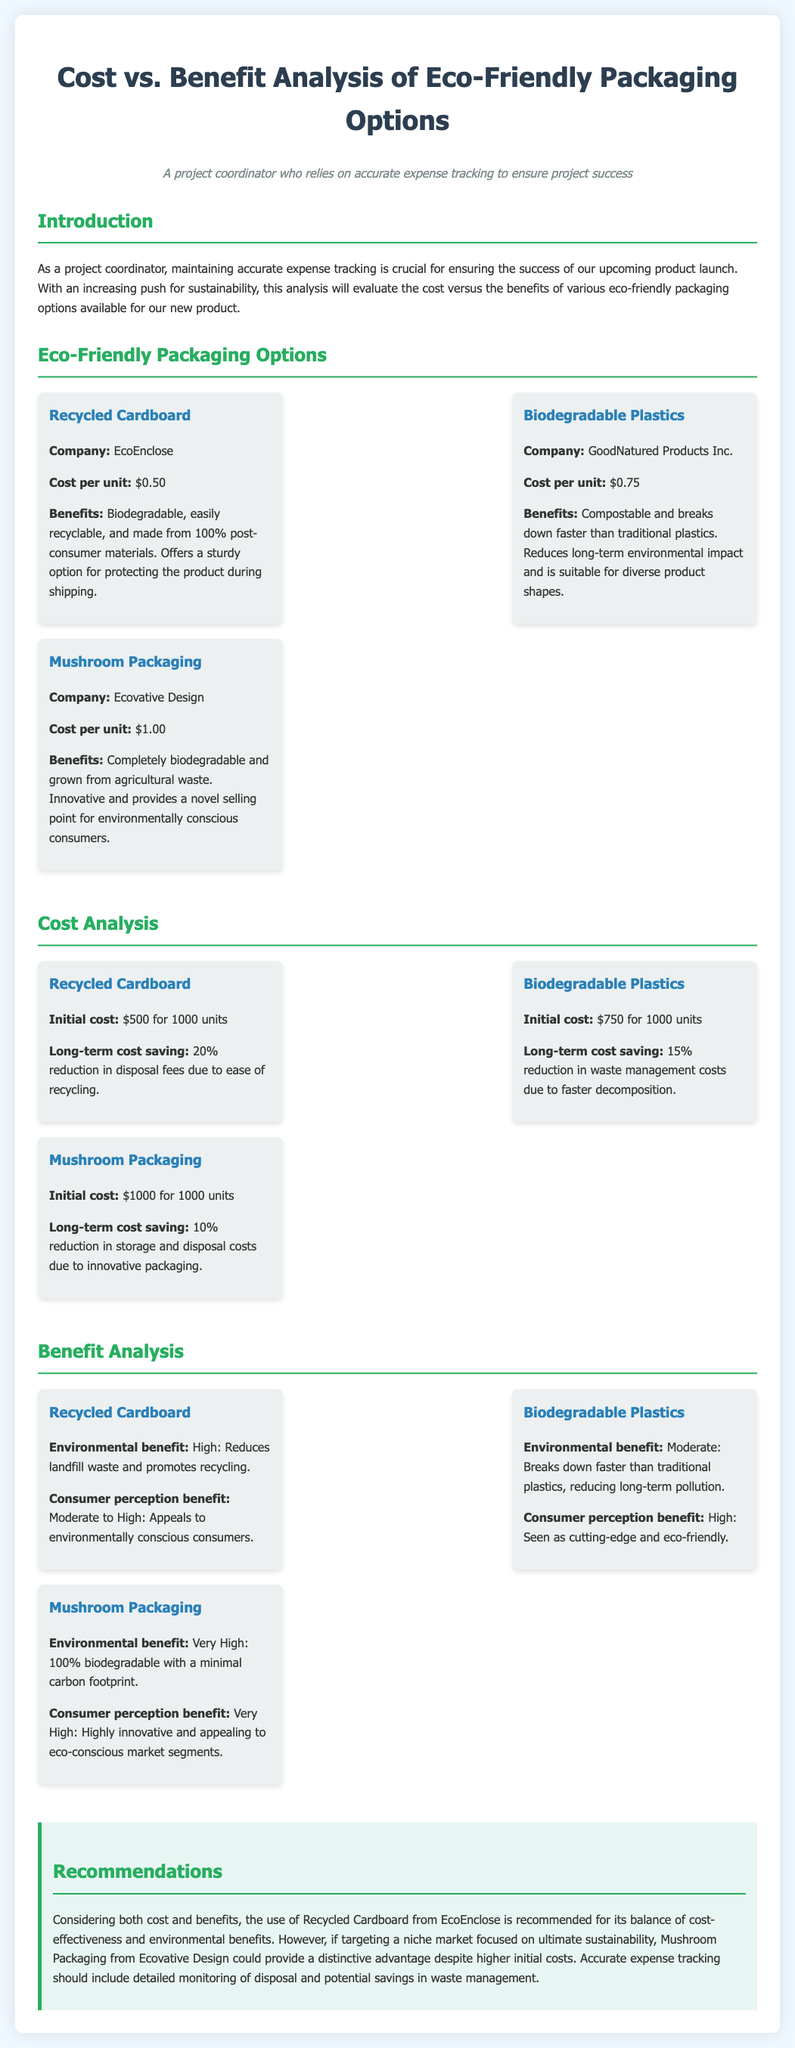What is the cost per unit of Recycled Cardboard? The cost per unit of Recycled Cardboard is provided as $0.50.
Answer: $0.50 What is the initial cost of Mushroom Packaging for 1000 units? The document states that the initial cost of Mushroom Packaging is $1000 for 1000 units.
Answer: $1000 Which option offers a 20% reduction in disposal fees? The analysis indicates that Recycled Cardboard offers a 20% reduction in disposal fees due to ease of recycling.
Answer: Recycled Cardboard What company produces Biodegradable Plastics? The company that produces Biodegradable Plastics is mentioned as GoodNatured Products Inc.
Answer: GoodNatured Products Inc Which packaging option is considered very high in environmental benefit? The document specifies that Mushroom Packaging has a very high environmental benefit due to being 100% biodegradable.
Answer: Mushroom Packaging What does the benefit analysis say about consumer perception for Biodegradable Plastics? The document states that the consumer perception benefit for Biodegradable Plastics is high.
Answer: High What is the recommended packaging option based on the analysis? According to the recommendations, Recycled Cardboard from EcoEnclose is recommended for its balance.
Answer: Recycled Cardboard What type of packaging could provide a distinctive advantage in a niche market? The analysis suggests that Mushroom Packaging could provide a distinctive advantage despite higher initial costs.
Answer: Mushroom Packaging What percentage reduction in waste management costs is associated with Biodegradable Plastics? The document indicates a 15% reduction in waste management costs associated with Biodegradable Plastics.
Answer: 15% 